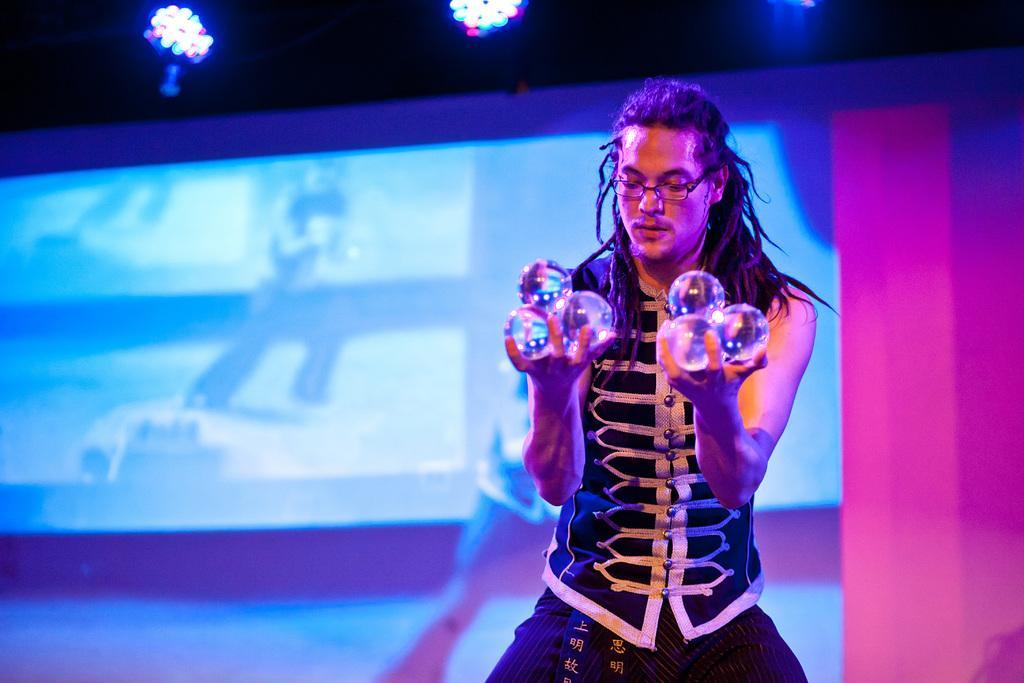Could you give a brief overview of what you see in this image? In this image I see a man who is wearing white and black dress and I see that he is holding things in his hands. In the background I see the screen and I see the lights and I see that it is dark over here. 